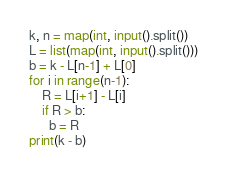Convert code to text. <code><loc_0><loc_0><loc_500><loc_500><_Python_>k, n = map(int, input().split())
L = list(map(int, input().split()))
b = k - L[n-1] + L[0]
for i in range(n-1):
    R = L[i+1] - L[i]
    if R > b:
      b = R
print(k - b)</code> 